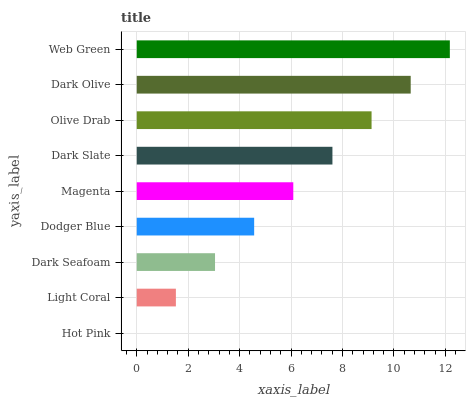Is Hot Pink the minimum?
Answer yes or no. Yes. Is Web Green the maximum?
Answer yes or no. Yes. Is Light Coral the minimum?
Answer yes or no. No. Is Light Coral the maximum?
Answer yes or no. No. Is Light Coral greater than Hot Pink?
Answer yes or no. Yes. Is Hot Pink less than Light Coral?
Answer yes or no. Yes. Is Hot Pink greater than Light Coral?
Answer yes or no. No. Is Light Coral less than Hot Pink?
Answer yes or no. No. Is Magenta the high median?
Answer yes or no. Yes. Is Magenta the low median?
Answer yes or no. Yes. Is Hot Pink the high median?
Answer yes or no. No. Is Dark Seafoam the low median?
Answer yes or no. No. 